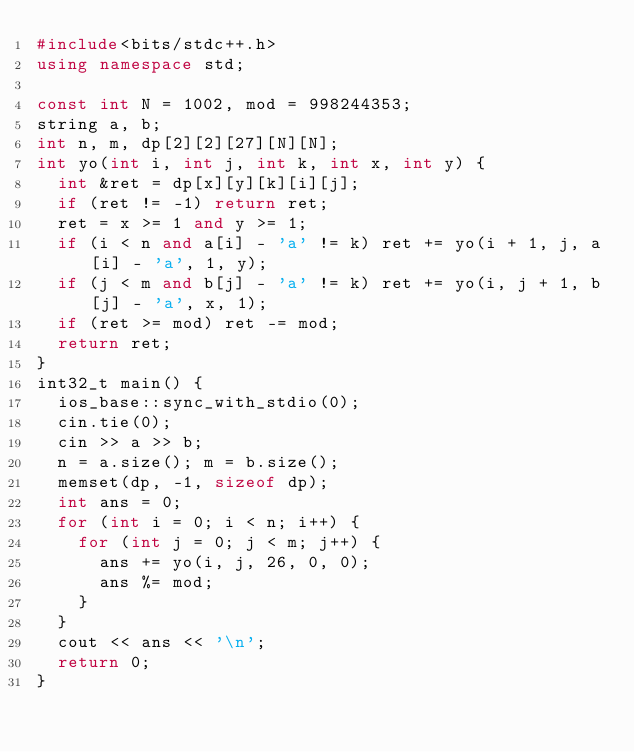Convert code to text. <code><loc_0><loc_0><loc_500><loc_500><_C++_>#include<bits/stdc++.h>
using namespace std;

const int N = 1002, mod = 998244353;
string a, b;
int n, m, dp[2][2][27][N][N];
int yo(int i, int j, int k, int x, int y) {
  int &ret = dp[x][y][k][i][j];
  if (ret != -1) return ret;
  ret = x >= 1 and y >= 1;
  if (i < n and a[i] - 'a' != k) ret += yo(i + 1, j, a[i] - 'a', 1, y);
  if (j < m and b[j] - 'a' != k) ret += yo(i, j + 1, b[j] - 'a', x, 1);
  if (ret >= mod) ret -= mod;
  return ret;
}
int32_t main() {
  ios_base::sync_with_stdio(0);
  cin.tie(0);
  cin >> a >> b;
  n = a.size(); m = b.size();
  memset(dp, -1, sizeof dp);
  int ans = 0;
  for (int i = 0; i < n; i++) {
    for (int j = 0; j < m; j++) {
      ans += yo(i, j, 26, 0, 0);
      ans %= mod;
    }
  }
  cout << ans << '\n';
  return 0;
}</code> 